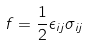<formula> <loc_0><loc_0><loc_500><loc_500>f = \frac { 1 } { 2 } \epsilon _ { i j } \sigma _ { i j }</formula> 